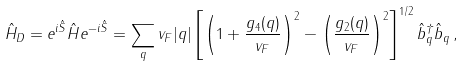<formula> <loc_0><loc_0><loc_500><loc_500>\hat { H } _ { D } = e ^ { i \hat { S } } \hat { H } e ^ { - i \hat { S } } = \sum _ { q } v _ { F } | q | \left [ \left ( 1 + \frac { g _ { 4 } ( q ) } { v _ { F } } \right ) ^ { 2 } - \left ( \frac { g _ { 2 } ( q ) } { v _ { F } } \right ) ^ { 2 } \right ] ^ { 1 / 2 } \hat { b } ^ { \dag } _ { q } \hat { b } _ { q } \, ,</formula> 